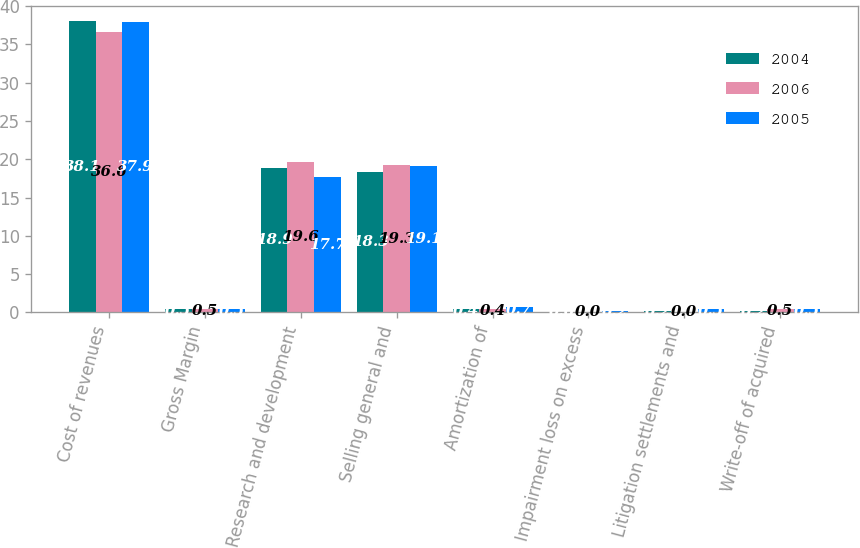Convert chart to OTSL. <chart><loc_0><loc_0><loc_500><loc_500><stacked_bar_chart><ecel><fcel>Cost of revenues<fcel>Gross Margin<fcel>Research and development<fcel>Selling general and<fcel>Amortization of<fcel>Impairment loss on excess<fcel>Litigation settlements and<fcel>Write-off of acquired<nl><fcel>2004<fcel>38.1<fcel>0.5<fcel>18.9<fcel>18.3<fcel>0.4<fcel>0<fcel>0.2<fcel>0.2<nl><fcel>2006<fcel>36.6<fcel>0.5<fcel>19.6<fcel>19.3<fcel>0.4<fcel>0<fcel>0<fcel>0.5<nl><fcel>2005<fcel>37.9<fcel>0.5<fcel>17.7<fcel>19.1<fcel>0.7<fcel>0.2<fcel>0.5<fcel>0.5<nl></chart> 